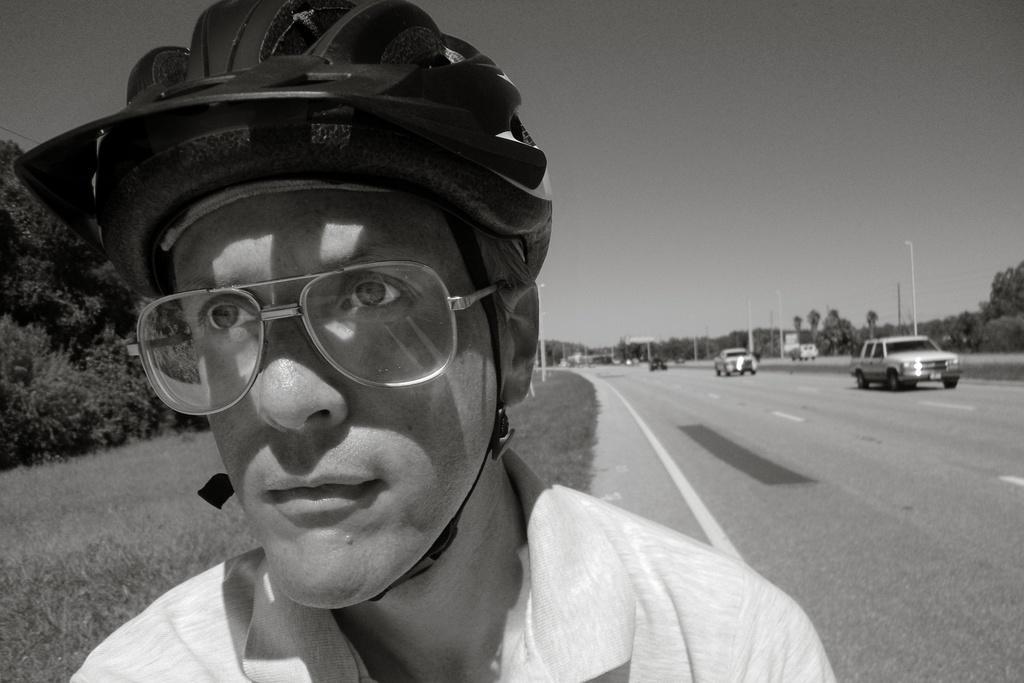How would you summarize this image in a sentence or two? In this image I can see a man in the front and I can see he is wearing shades, a helmet and t-shirt. On the right side of this image I can see a road and on it I can see number of vehicles. On the both sides of the road I can see number of trees, grass, number of poles, lights and I can see this images black and white in colour. 